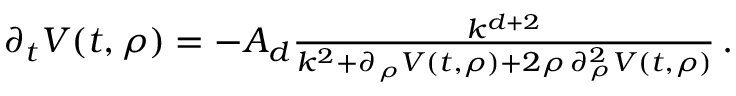<formula> <loc_0><loc_0><loc_500><loc_500>\begin{array} { r } { \partial _ { t } V ( t , \rho ) = - A _ { d } \frac { k ^ { d + 2 } } { k ^ { 2 } + \partial _ { \rho } V ( t , \rho ) + 2 \rho \, \partial _ { \rho } ^ { 2 } V ( t , \rho ) } \, . } \end{array}</formula> 